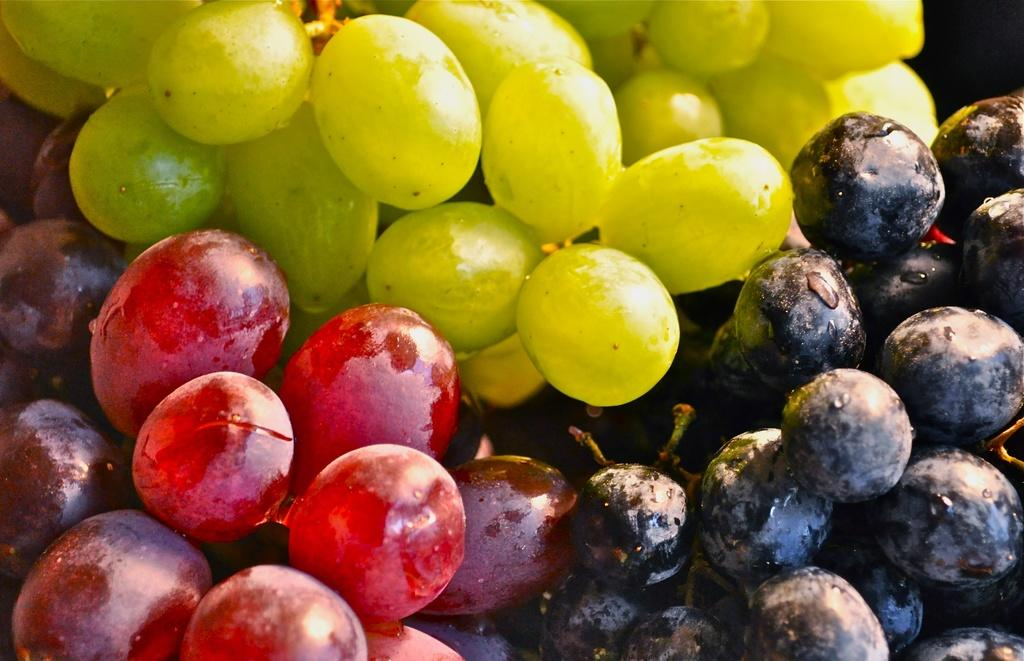What type of fruit is present in the image? There are different types of color grapes in the image. Can you describe the color of the grapes? The grapes have different colors. What might someone do with the grapes in the image? Someone might eat, juice, or use the grapes for decoration. What type of dinosaur can be seen in the image? There are no dinosaurs present in the image; it features different types of color grapes. Can you describe the owl's behavior in the image? There is no owl present in the image; it only contains grapes. 